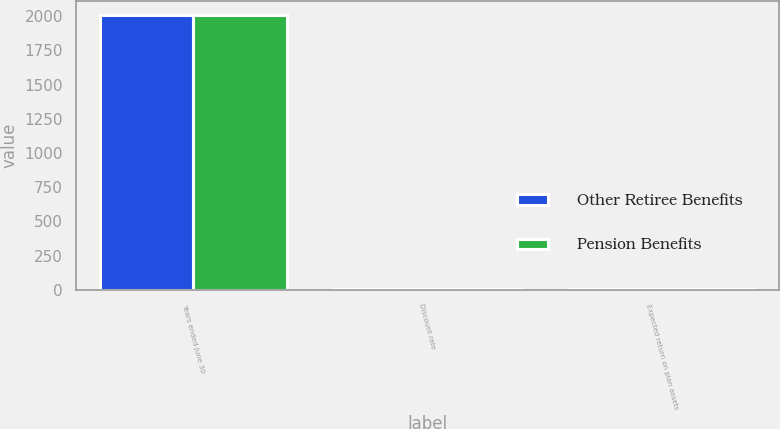Convert chart to OTSL. <chart><loc_0><loc_0><loc_500><loc_500><stacked_bar_chart><ecel><fcel>Years ended June 30<fcel>Discount rate<fcel>Expected return on plan assets<nl><fcel>Other Retiree Benefits<fcel>2012<fcel>4.2<fcel>7.4<nl><fcel>Pension Benefits<fcel>2012<fcel>4.3<fcel>9.2<nl></chart> 